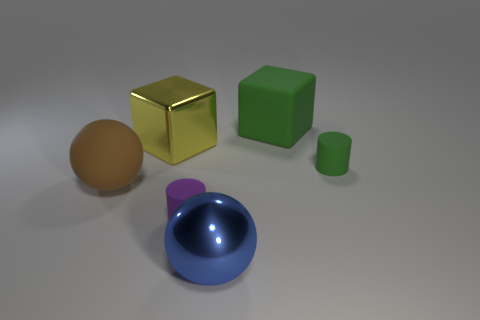Add 2 big cubes. How many objects exist? 8 Subtract all cubes. How many objects are left? 4 Subtract 1 balls. How many balls are left? 1 Subtract all green blocks. How many blocks are left? 1 Subtract all gray spheres. How many yellow blocks are left? 1 Subtract all cyan metal cubes. Subtract all large brown objects. How many objects are left? 5 Add 1 large cubes. How many large cubes are left? 3 Add 1 blocks. How many blocks exist? 3 Subtract 0 blue cylinders. How many objects are left? 6 Subtract all red cylinders. Subtract all red blocks. How many cylinders are left? 2 